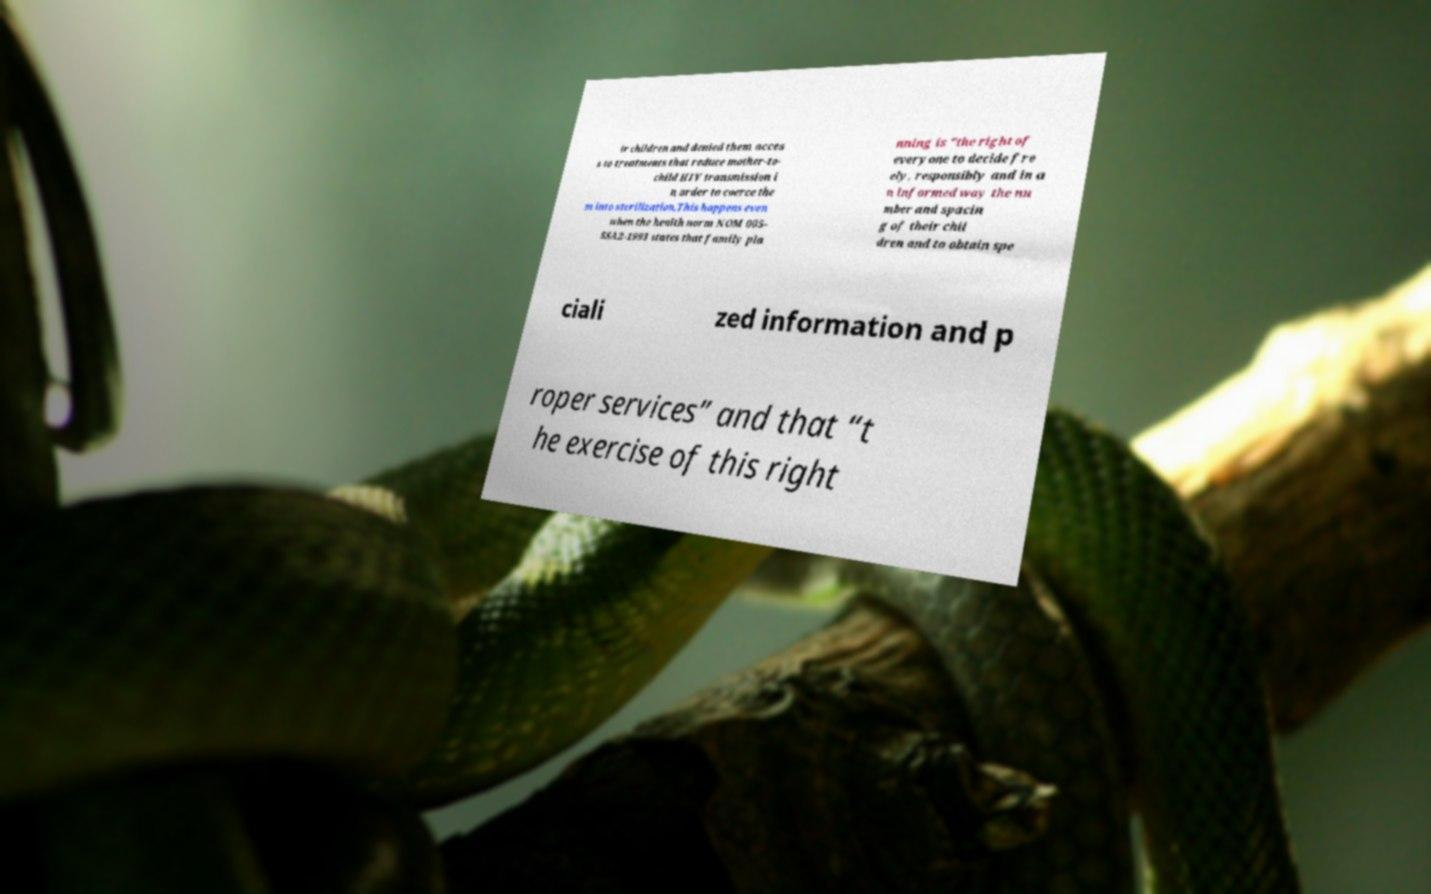I need the written content from this picture converted into text. Can you do that? ir children and denied them acces s to treatments that reduce mother-to- child HIV transmission i n order to coerce the m into sterilization.This happens even when the health norm NOM 005- SSA2-1993 states that family pla nning is "the right of everyone to decide fre ely, responsibly and in a n informed way the nu mber and spacin g of their chil dren and to obtain spe ciali zed information and p roper services” and that “t he exercise of this right 